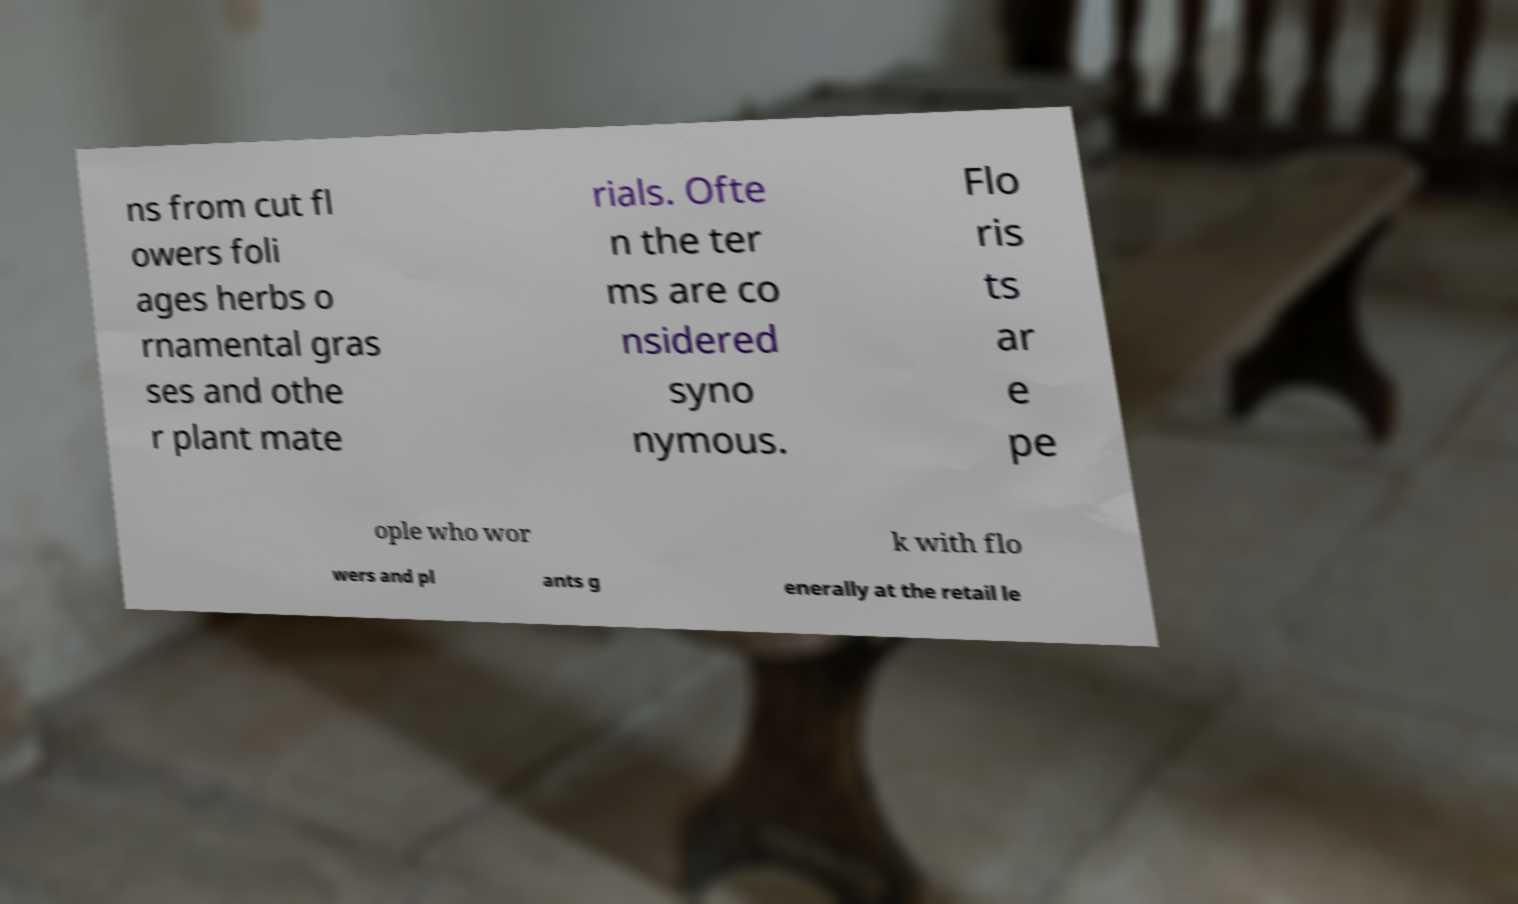Can you read and provide the text displayed in the image?This photo seems to have some interesting text. Can you extract and type it out for me? ns from cut fl owers foli ages herbs o rnamental gras ses and othe r plant mate rials. Ofte n the ter ms are co nsidered syno nymous. Flo ris ts ar e pe ople who wor k with flo wers and pl ants g enerally at the retail le 